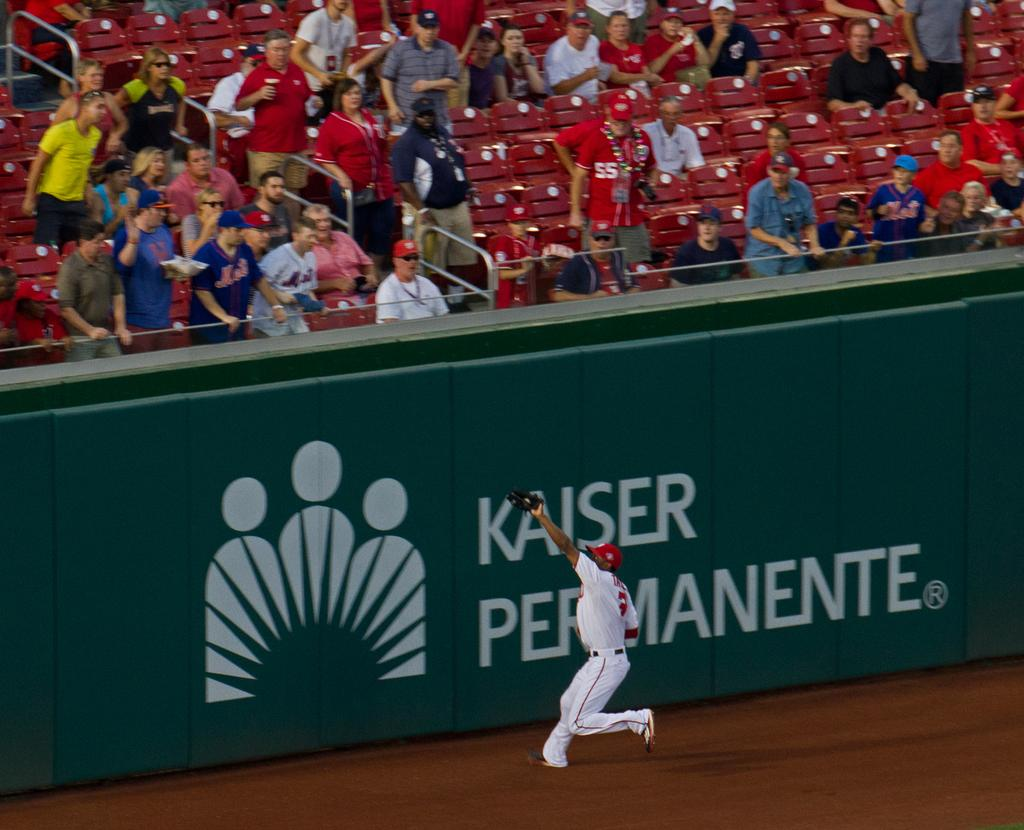<image>
Create a compact narrative representing the image presented. A player catches a ball in front of an ad for Kaiser Permanente 